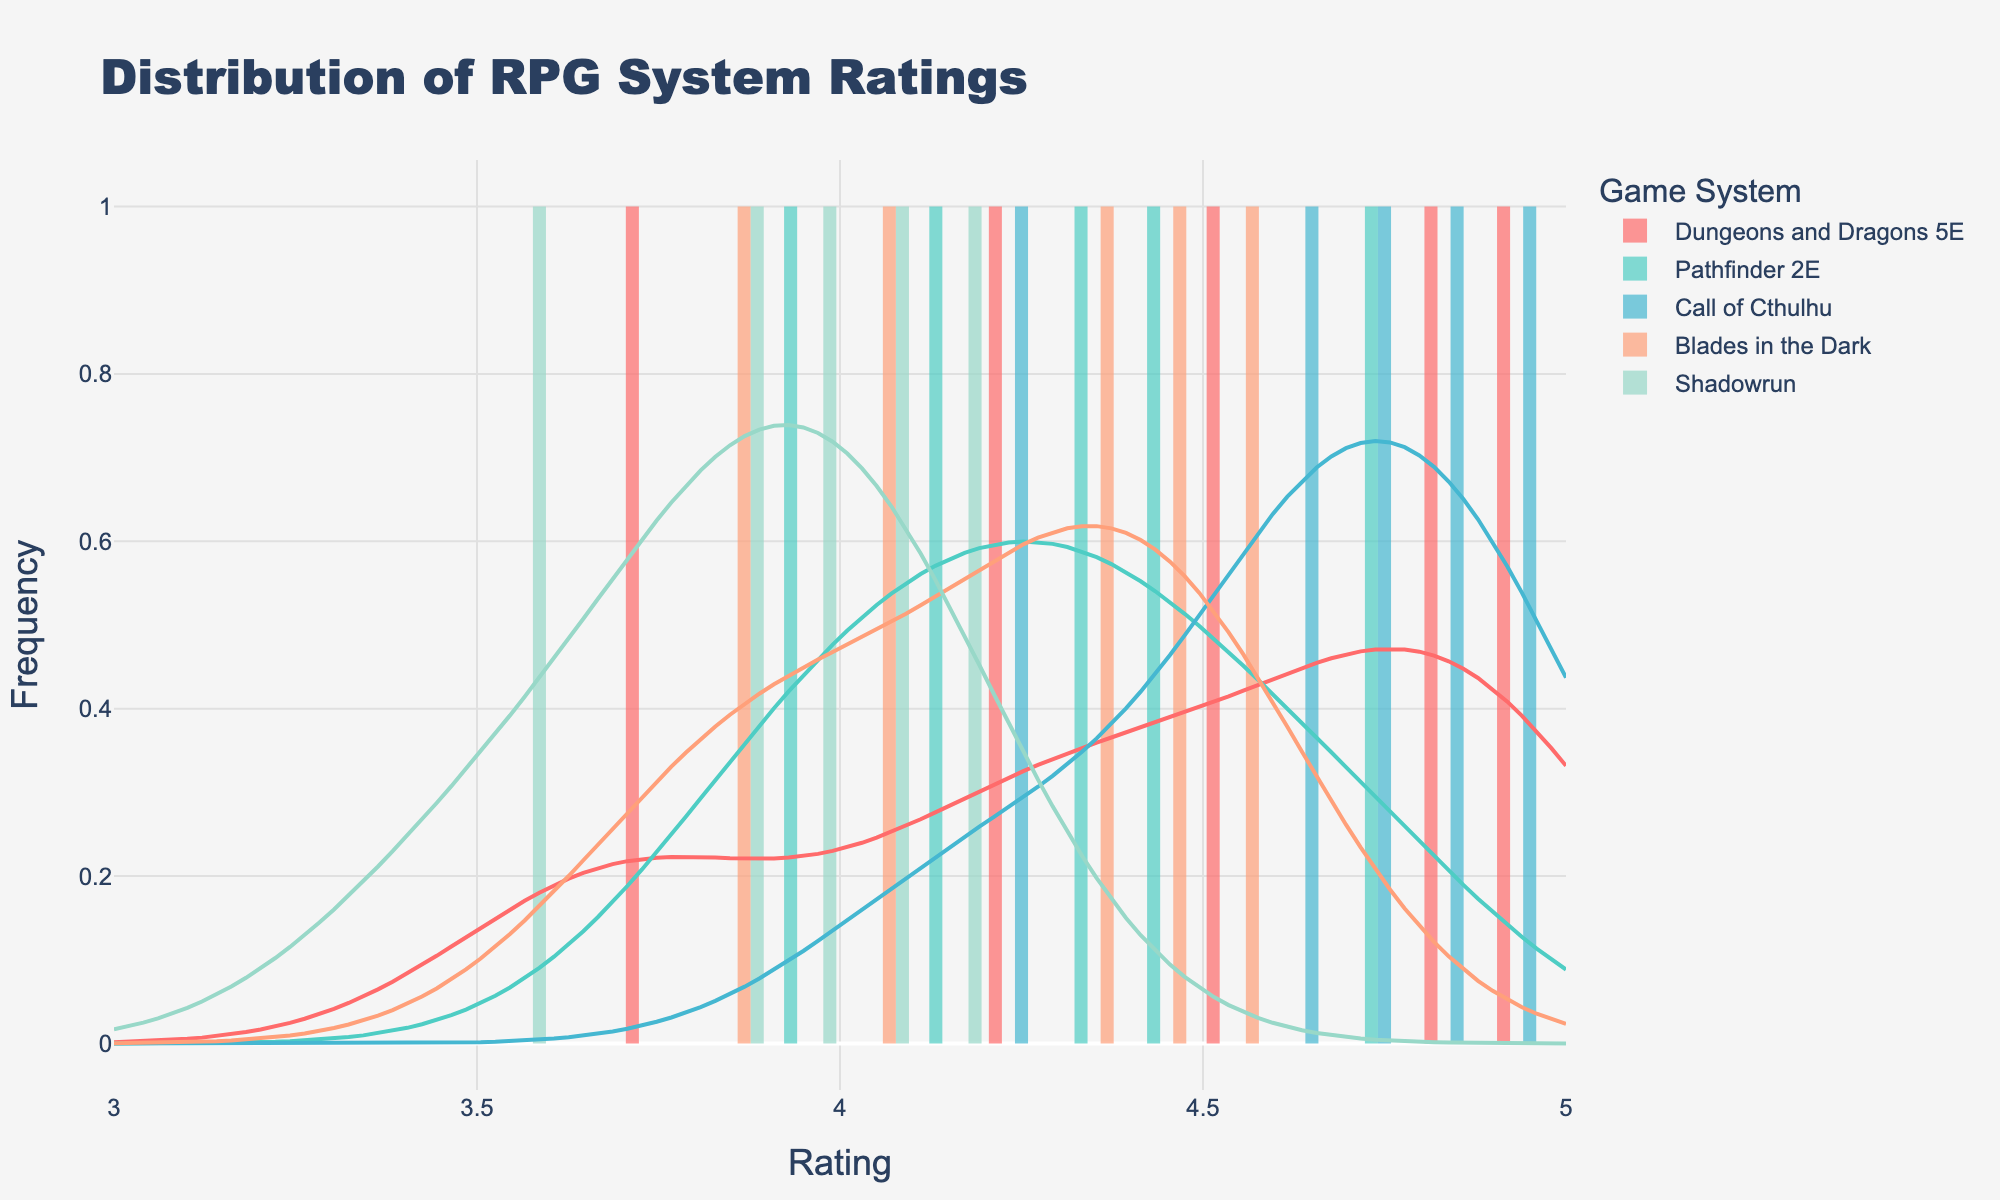What is the title of the figure? The title of the figure is placed prominently at the top and reads 'Distribution of RPG System Ratings'.
Answer: Distribution of RPG System Ratings What is the range of the x-axis? The x-axis shows rating values, and its range is set from 3 to 5, as indicated by its start and end points.
Answer: 3 to 5 Which RPG system has the highest peak in the KDE (Kernel Density Estimate) plot? Looking at the KDE plots for each game system, the highest peak is visibly seen in the Call of Cthulhu KDE plot.
Answer: Call of Cthulhu How many rating bins are used in the histogram plots? The histogram x-axis ranges from 3 to 5 are divided into bins of size 0.1, meaning there are (5-3)/0.1 = 20 bins.
Answer: 20 Which RPG system appears to have the lowest average rating? Identifying the KDE plots, Shadowrun shows peaks at lower rating values (around 3.5), suggesting it has the lowest average rating.
Answer: Shadowrun Comparing Dungeons & Dragons 5E and Pathfinder 2E, which system has a wider range of ratings? Dungeons & Dragons 5E's ratings range from about 3.7 to 4.9, while Pathfinder 2E's ratings range from roughly 3.9 to 4.7. Thus, D&D 5E has a wider range.
Answer: Dungeons & Dragons 5E Which game system has ratings clustered mostly between 4.2 and 4.5? From the KDE plots, Blades in the Dark has peaks and a higher density of ratings in the range of 4.2 to 4.5.
Answer: Blades in the Dark How does the frequency of ratings for Call of Cthulhu compare to that of Shadowrun? The histogram and KDE plots show Call of Cthulhu having higher peaks and more frequent high ratings than Shadowrun, which peaks at lower rating values.
Answer: Call of Cthulhu has higher frequency Looking at the legend, how many different RPG systems are represented? The legend shows five different RPG systems: Dungeons and Dragons 5E, Pathfinder 2E, Call of Cthulhu, Blades in the Dark, and Shadowrun.
Answer: 5 